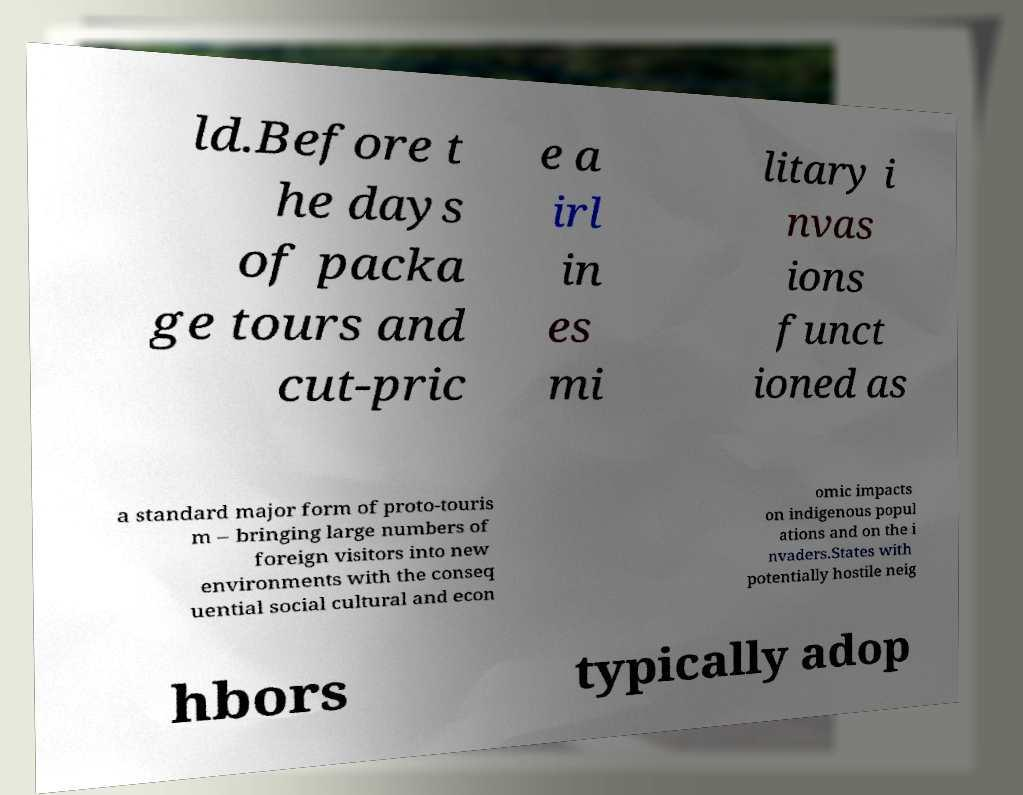There's text embedded in this image that I need extracted. Can you transcribe it verbatim? ld.Before t he days of packa ge tours and cut-pric e a irl in es mi litary i nvas ions funct ioned as a standard major form of proto-touris m – bringing large numbers of foreign visitors into new environments with the conseq uential social cultural and econ omic impacts on indigenous popul ations and on the i nvaders.States with potentially hostile neig hbors typically adop 